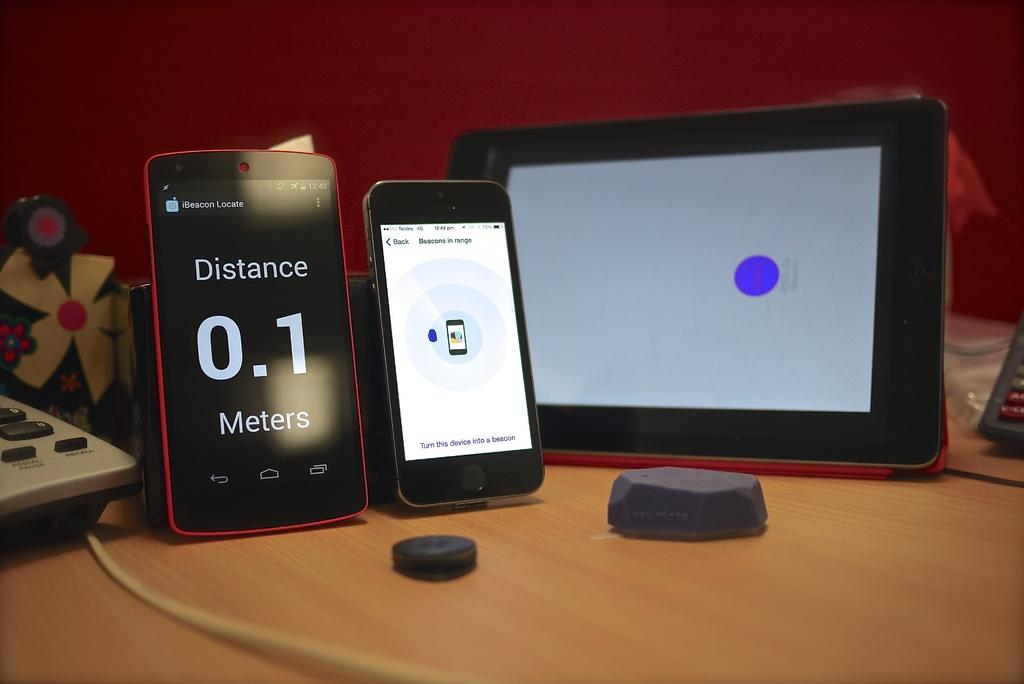How many cell phones are visible in the image? There are two cell phones in the image. Where are the cell phones located in the image? The cell phones are on the left side of the image. What other device can be seen in the image besides the cell phones? There is a tablet in the image. Where is the tablet located in the image? The tablet is in the center of the image. On what surface are all the devices placed? All the devices are placed on a table. What type of hat is being used as a pest control device in the image? There is no hat or pest control device present in the image. 